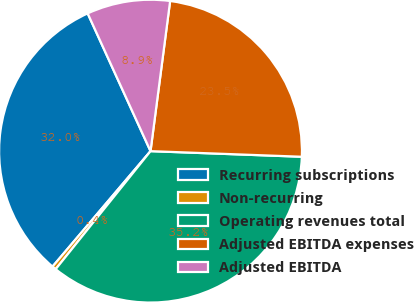Convert chart to OTSL. <chart><loc_0><loc_0><loc_500><loc_500><pie_chart><fcel>Recurring subscriptions<fcel>Non-recurring<fcel>Operating revenues total<fcel>Adjusted EBITDA expenses<fcel>Adjusted EBITDA<nl><fcel>31.98%<fcel>0.43%<fcel>35.18%<fcel>23.52%<fcel>8.88%<nl></chart> 